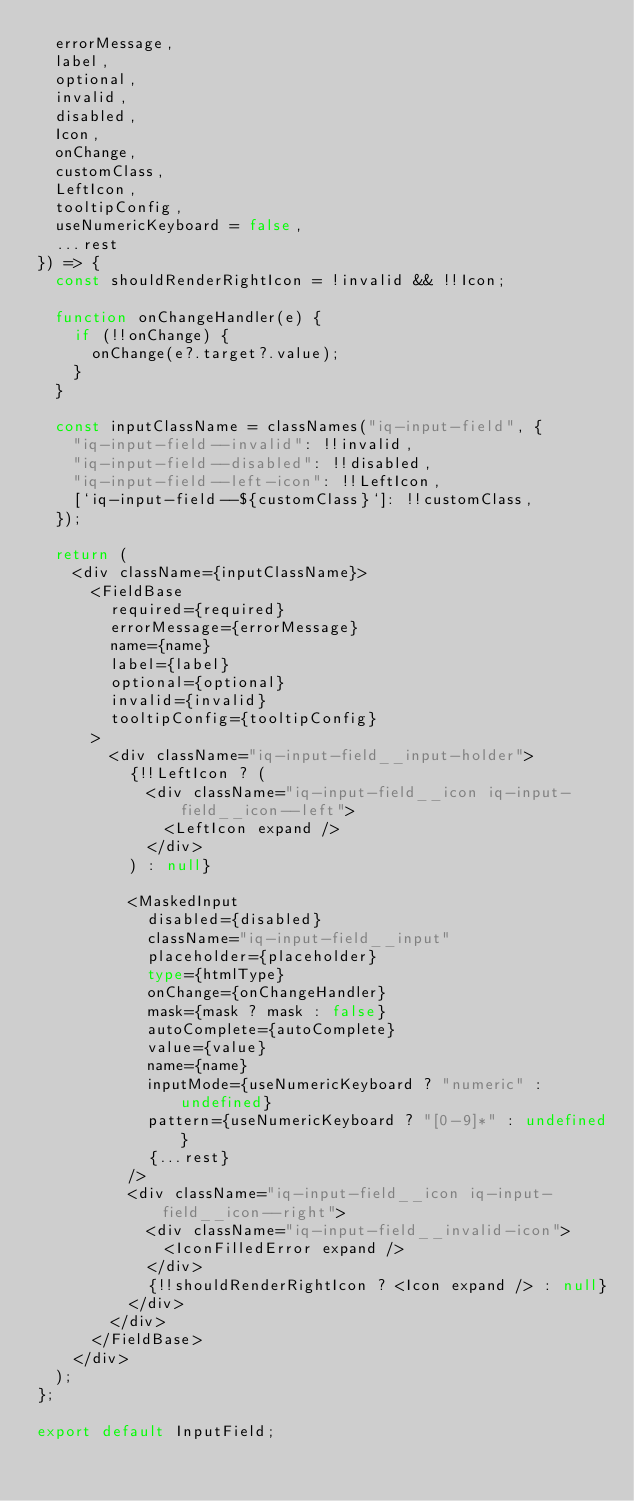Convert code to text. <code><loc_0><loc_0><loc_500><loc_500><_TypeScript_>  errorMessage,
  label,
  optional,
  invalid,
  disabled,
  Icon,
  onChange,
  customClass,
  LeftIcon,
  tooltipConfig,
  useNumericKeyboard = false,
  ...rest
}) => {
  const shouldRenderRightIcon = !invalid && !!Icon;

  function onChangeHandler(e) {
    if (!!onChange) {
      onChange(e?.target?.value);
    }
  }

  const inputClassName = classNames("iq-input-field", {
    "iq-input-field--invalid": !!invalid,
    "iq-input-field--disabled": !!disabled,
    "iq-input-field--left-icon": !!LeftIcon,
    [`iq-input-field--${customClass}`]: !!customClass,
  });

  return (
    <div className={inputClassName}>
      <FieldBase
        required={required}
        errorMessage={errorMessage}
        name={name}
        label={label}
        optional={optional}
        invalid={invalid}
        tooltipConfig={tooltipConfig}
      >
        <div className="iq-input-field__input-holder">
          {!!LeftIcon ? (
            <div className="iq-input-field__icon iq-input-field__icon--left">
              <LeftIcon expand />
            </div>
          ) : null}

          <MaskedInput
            disabled={disabled}
            className="iq-input-field__input"
            placeholder={placeholder}
            type={htmlType}
            onChange={onChangeHandler}
            mask={mask ? mask : false}
            autoComplete={autoComplete}
            value={value}
            name={name}
            inputMode={useNumericKeyboard ? "numeric" : undefined}
            pattern={useNumericKeyboard ? "[0-9]*" : undefined}
            {...rest}
          />
          <div className="iq-input-field__icon iq-input-field__icon--right">
            <div className="iq-input-field__invalid-icon">
              <IconFilledError expand />
            </div>
            {!!shouldRenderRightIcon ? <Icon expand /> : null}
          </div>
        </div>
      </FieldBase>
    </div>
  );
};

export default InputField;
</code> 